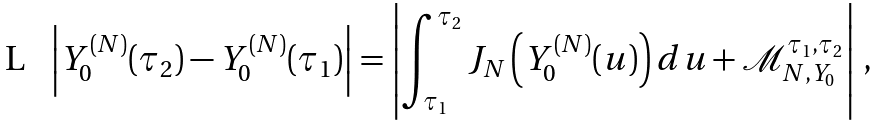<formula> <loc_0><loc_0><loc_500><loc_500>\left | Y _ { 0 } ^ { ( N ) } ( \tau _ { 2 } ) - Y _ { 0 } ^ { ( N ) } ( \tau _ { 1 } ) \right | = \left | \int _ { \tau _ { 1 } } ^ { \tau _ { 2 } } J _ { N } \left ( Y _ { 0 } ^ { ( N ) } ( u ) \right ) d u + \mathcal { M } _ { N , Y _ { 0 } } ^ { \tau _ { 1 } , \tau _ { 2 } } \right | \, ,</formula> 